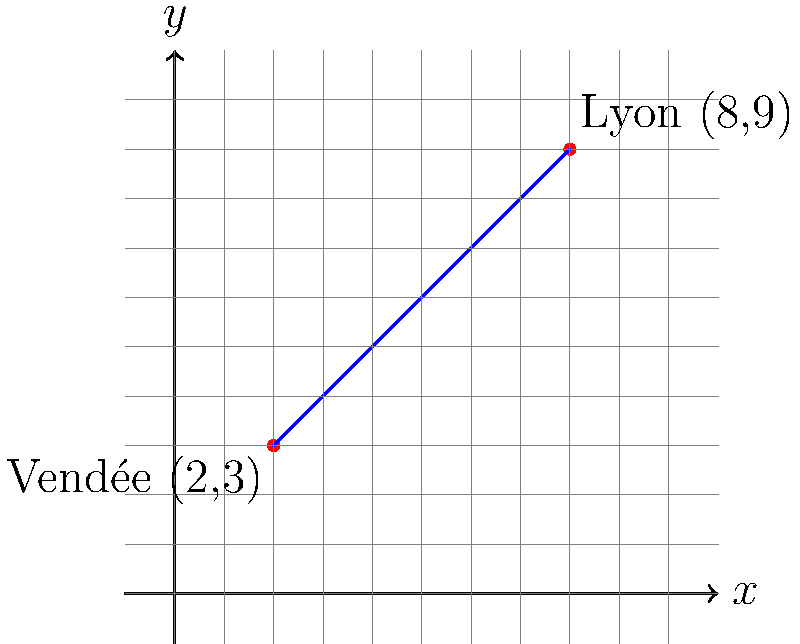During the Reign of Terror, two significant battle sites were Vendée and Lyon. On a coordinate plane, Vendée is represented by the point (2,3) and Lyon by (8,9). Calculate the slope of the line connecting these two locations. How might this slope reflect the spread of revolutionary fervor across France, despite the questionable methods employed by the Committee of Public Safety? To find the slope of the line connecting Vendée (2,3) and Lyon (8,9), we'll use the slope formula:

$$ m = \frac{y_2 - y_1}{x_2 - x_1} $$

Where $(x_1, y_1)$ represents Vendée (2,3) and $(x_2, y_2)$ represents Lyon (8,9).

Step 1: Identify the coordinates
Vendée: $(x_1, y_1) = (2, 3)$
Lyon: $(x_2, y_2) = (8, 9)$

Step 2: Apply the slope formula
$$ m = \frac{9 - 3}{8 - 2} = \frac{6}{6} $$

Step 3: Simplify
$$ m = 1 $$

The slope of 1 indicates a steady, positive increase. In the context of the French Revolution, this could be interpreted as the relentless spread of revolutionary ideals from western France (Vendée) to the southeast (Lyon). However, it's worth noting that this "progress" came at a terrible cost, with both Vendée and Lyon experiencing brutal repressions during the Reign of Terror. The linear nature of this spread might suggest a calculated and systematic approach by the Committee of Public Safety, rather than a natural, organic growth of revolutionary sentiment.
Answer: $1$ 